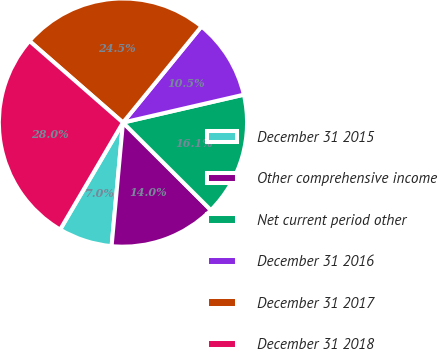<chart> <loc_0><loc_0><loc_500><loc_500><pie_chart><fcel>December 31 2015<fcel>Other comprehensive income<fcel>Net current period other<fcel>December 31 2016<fcel>December 31 2017<fcel>December 31 2018<nl><fcel>6.99%<fcel>13.99%<fcel>16.08%<fcel>10.49%<fcel>24.48%<fcel>27.97%<nl></chart> 